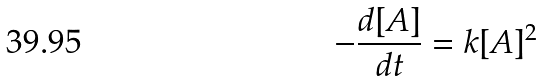Convert formula to latex. <formula><loc_0><loc_0><loc_500><loc_500>- \frac { d [ A ] } { d t } = k [ A ] ^ { 2 }</formula> 